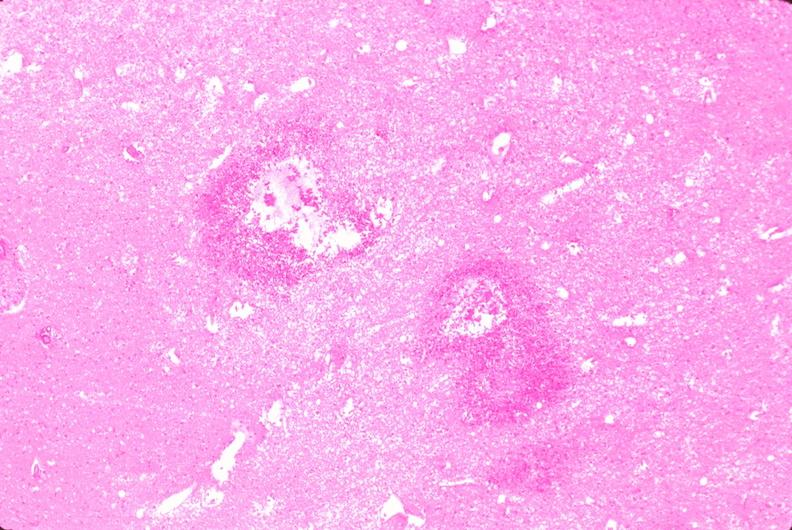where is this?
Answer the question using a single word or phrase. Nervous 